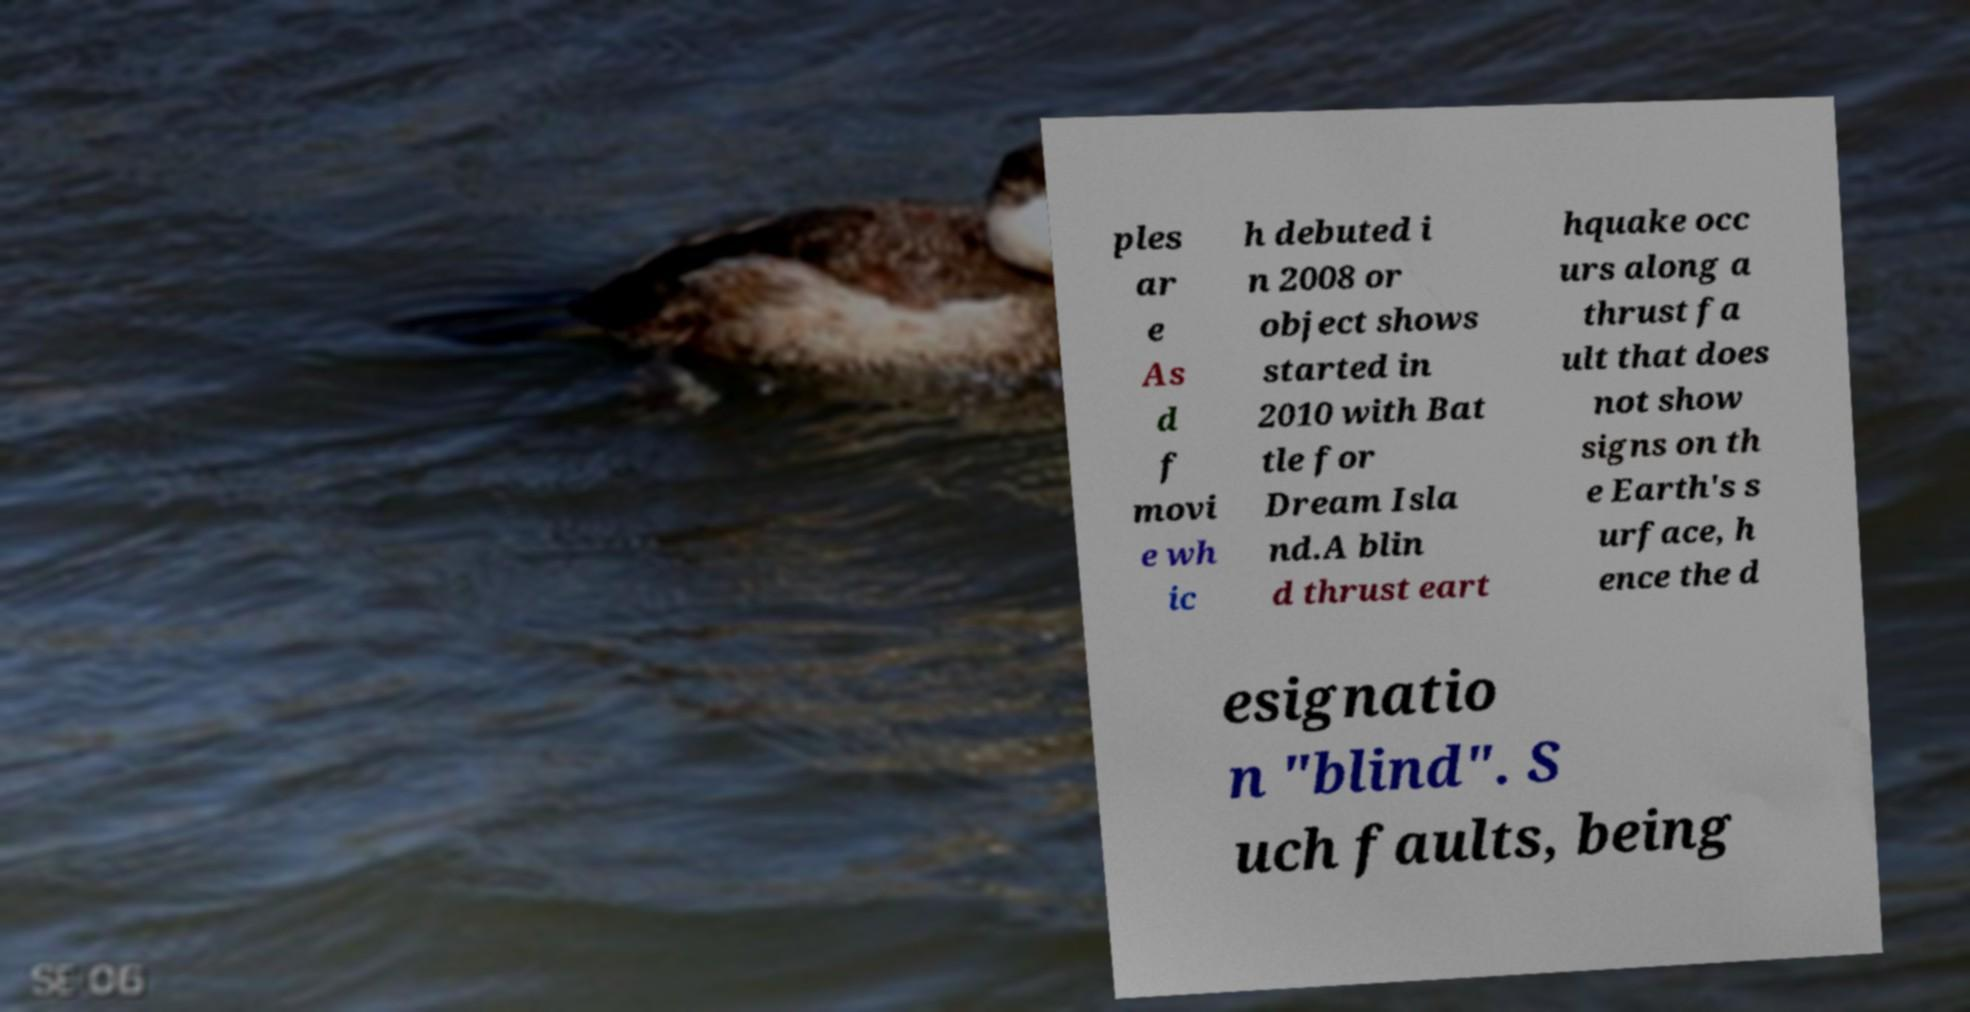There's text embedded in this image that I need extracted. Can you transcribe it verbatim? ples ar e As d f movi e wh ic h debuted i n 2008 or object shows started in 2010 with Bat tle for Dream Isla nd.A blin d thrust eart hquake occ urs along a thrust fa ult that does not show signs on th e Earth's s urface, h ence the d esignatio n "blind". S uch faults, being 